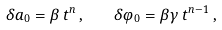<formula> <loc_0><loc_0><loc_500><loc_500>\delta a _ { 0 } = \beta \, t ^ { n } \, , \quad \delta \varphi _ { 0 } = \beta \gamma \, t ^ { n - 1 } \, ,</formula> 